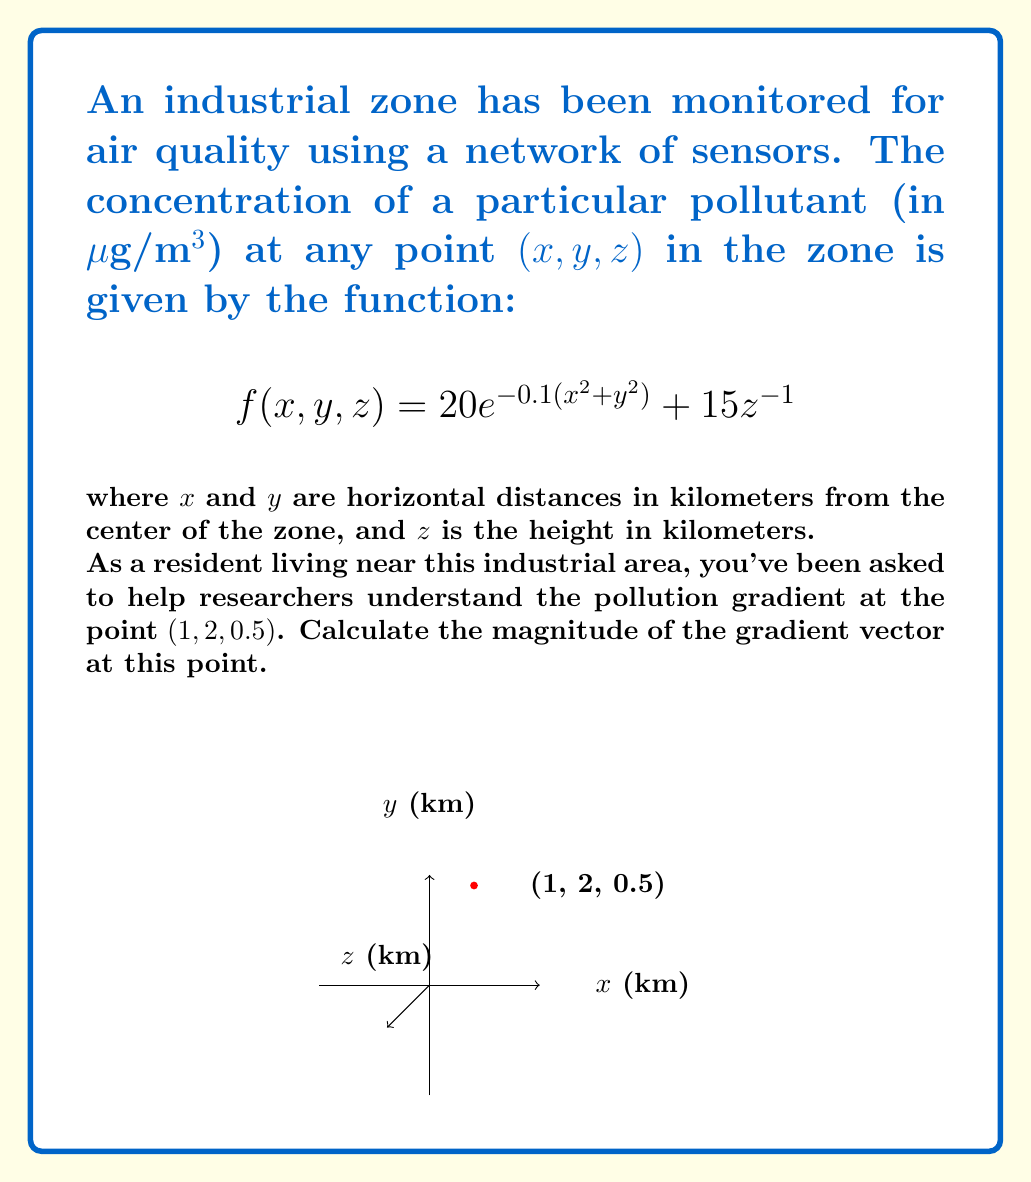Show me your answer to this math problem. Let's approach this step-by-step:

1) The gradient of a scalar field $f(x,y,z)$ is given by:

   $$\nabla f = \left(\frac{\partial f}{\partial x}, \frac{\partial f}{\partial y}, \frac{\partial f}{\partial z}\right)$$

2) Let's calculate each partial derivative:

   $$\frac{\partial f}{\partial x} = -4xe^{-0.1(x^2+y^2)}$$
   
   $$\frac{\partial f}{\partial y} = -4ye^{-0.1(x^2+y^2)}$$
   
   $$\frac{\partial f}{\partial z} = -15z^{-2}$$

3) Now, we need to evaluate these at the point (1, 2, 0.5):

   $$\frac{\partial f}{\partial x}\bigg|_{(1,2,0.5)} = -4(1)e^{-0.1(1^2+2^2)} = -4e^{-0.5}$$
   
   $$\frac{\partial f}{\partial y}\bigg|_{(1,2,0.5)} = -4(2)e^{-0.1(1^2+2^2)} = -8e^{-0.5}$$
   
   $$\frac{\partial f}{\partial z}\bigg|_{(1,2,0.5)} = -15(0.5)^{-2} = -60$$

4) The gradient vector at (1, 2, 0.5) is:

   $$\nabla f(1,2,0.5) = (-4e^{-0.5}, -8e^{-0.5}, -60)$$

5) The magnitude of this vector is:

   $$\|\nabla f(1,2,0.5)\| = \sqrt{((-4e^{-0.5})^2 + (-8e^{-0.5})^2 + (-60)^2}$$

6) Simplifying:

   $$\|\nabla f(1,2,0.5)\| = \sqrt{16e^{-1} + 64e^{-1} + 3600}$$
   
   $$= \sqrt{80e^{-1} + 3600}$$
   
   $$\approx 60.07$$

Therefore, the magnitude of the gradient vector at (1, 2, 0.5) is approximately 60.07 μg/m³/km.
Answer: 60.07 μg/m³/km 